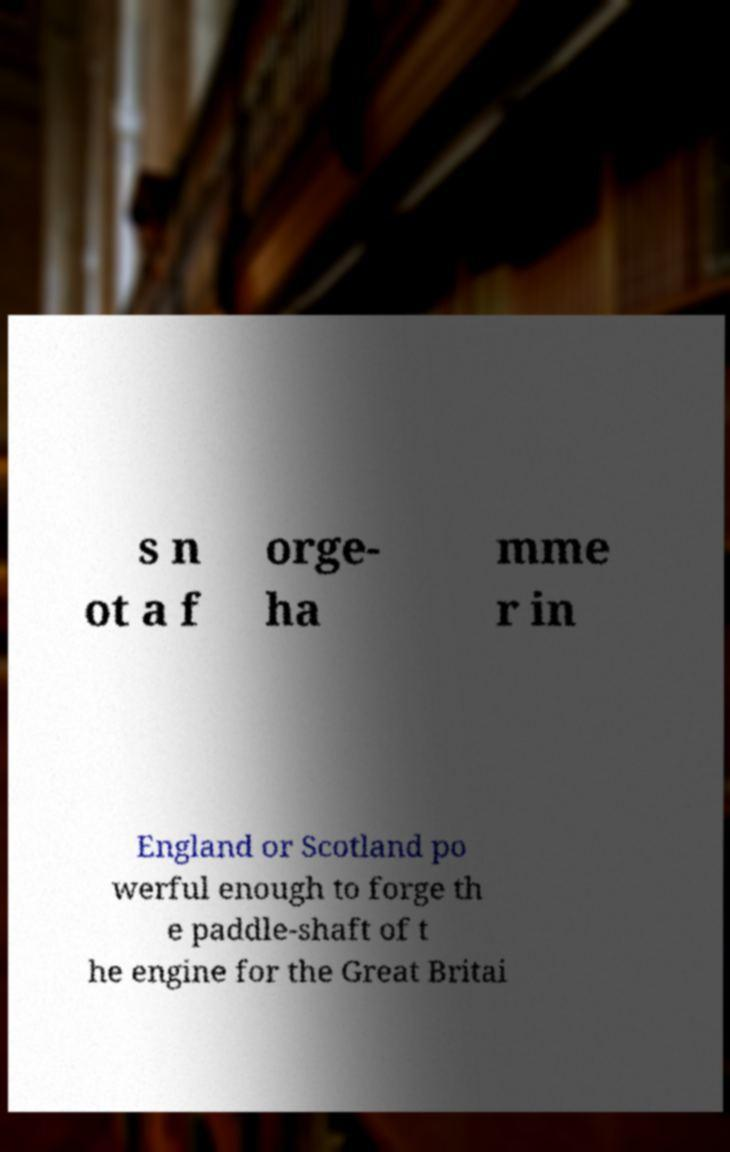Could you extract and type out the text from this image? s n ot a f orge- ha mme r in England or Scotland po werful enough to forge th e paddle-shaft of t he engine for the Great Britai 